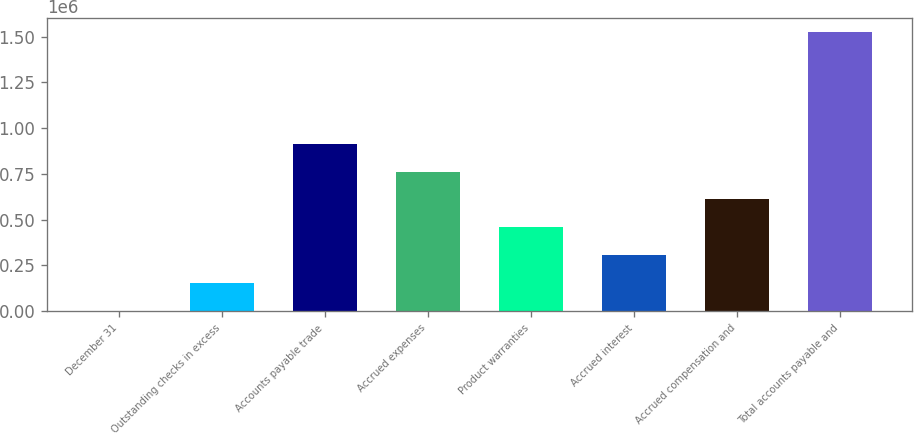Convert chart. <chart><loc_0><loc_0><loc_500><loc_500><bar_chart><fcel>December 31<fcel>Outstanding checks in excess<fcel>Accounts payable trade<fcel>Accrued expenses<fcel>Product warranties<fcel>Accrued interest<fcel>Accrued compensation and<fcel>Total accounts payable and<nl><fcel>2018<fcel>154203<fcel>915127<fcel>762942<fcel>458572<fcel>306388<fcel>610757<fcel>1.52387e+06<nl></chart> 